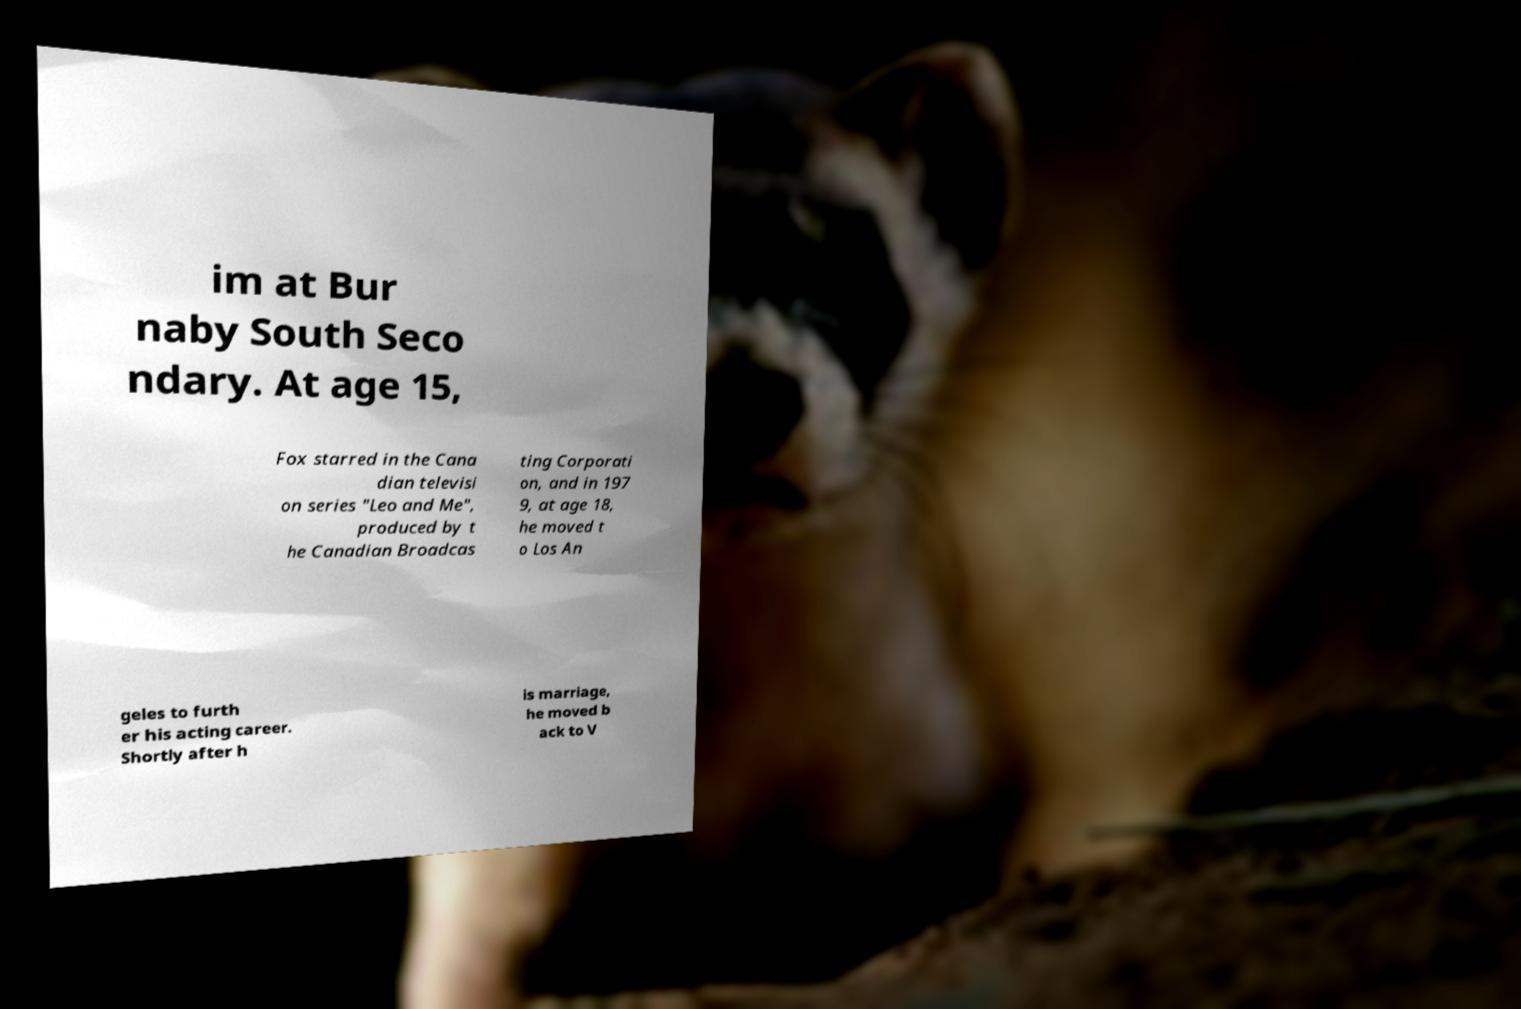There's text embedded in this image that I need extracted. Can you transcribe it verbatim? im at Bur naby South Seco ndary. At age 15, Fox starred in the Cana dian televisi on series "Leo and Me", produced by t he Canadian Broadcas ting Corporati on, and in 197 9, at age 18, he moved t o Los An geles to furth er his acting career. Shortly after h is marriage, he moved b ack to V 